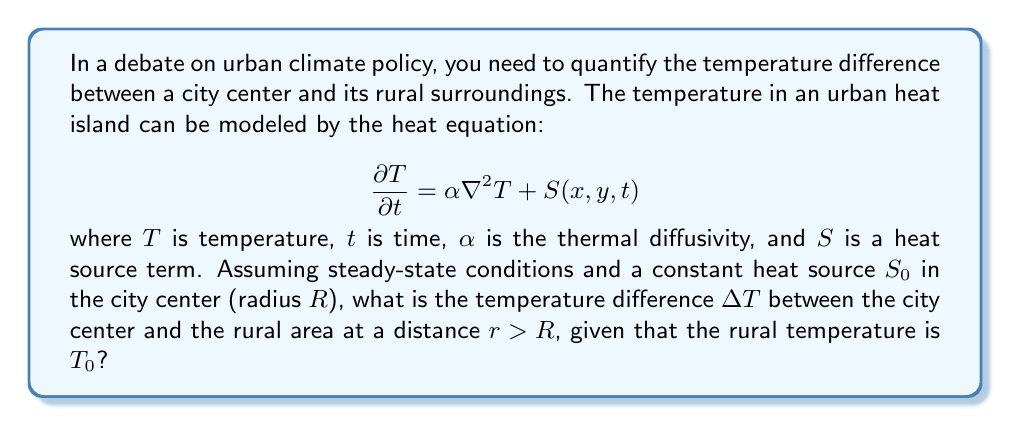Show me your answer to this math problem. To solve this problem, we'll follow these steps:

1) In steady-state conditions, $\frac{\partial T}{\partial t} = 0$, so our equation becomes:

   $$\alpha \nabla^2 T + S(x,y) = 0$$

2) Assuming radial symmetry, we can express the Laplacian in polar coordinates:

   $$\alpha \left(\frac{1}{r}\frac{d}{dr}\left(r\frac{dT}{dr}\right)\right) + S(r) = 0$$

3) The heat source term $S(r)$ is:

   $$S(r) = \begin{cases} 
   S_0 & \text{for } r \leq R \\
   0 & \text{for } r > R
   \end{cases}$$

4) For $r > R$ (outside the city), the equation becomes:

   $$\frac{1}{r}\frac{d}{dr}\left(r\frac{dT}{dr}\right) = 0$$

5) Integrating twice:

   $$T(r) = C_1 \ln(r) + C_2$$

6) At $r \to \infty$, $T = T_0$, so $C_1 = 0$ and $C_2 = T_0$

7) For $r \leq R$ (inside the city), the equation is:

   $$\frac{1}{r}\frac{d}{dr}\left(r\frac{dT}{dr}\right) = -\frac{S_0}{\alpha}$$

8) Integrating twice:

   $$T(r) = -\frac{S_0}{4\alpha}r^2 + C_3 \ln(r) + C_4$$

9) At $r = 0$, $T$ must be finite, so $C_3 = 0$

10) At $r = R$, temperature and its derivative must be continuous:

    $$-\frac{S_0}{4\alpha}R^2 + C_4 = T_0$$
    $$-\frac{S_0}{2\alpha}R = 0$$

11) From these conditions:

    $$C_4 = T_0 + \frac{S_0}{4\alpha}R^2$$

12) The temperature difference $\Delta T$ is:

    $$\Delta T = T(0) - T_0 = \frac{S_0}{4\alpha}R^2$$

This represents the maximum temperature difference between the city center and the rural area.
Answer: $\Delta T = \frac{S_0}{4\alpha}R^2$ 